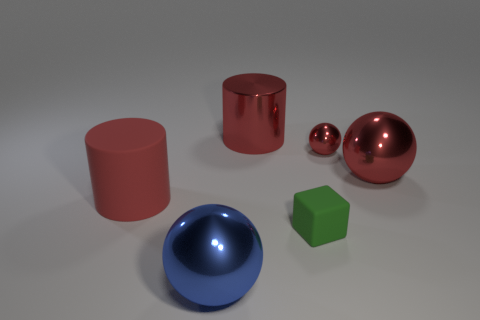There is a rubber object that is to the right of the large sphere in front of the large ball behind the blue sphere; what is its shape?
Your response must be concise. Cube. What size is the red thing that is behind the big red shiny ball and to the right of the small rubber thing?
Offer a terse response. Small. What number of small shiny balls are the same color as the large matte object?
Offer a very short reply. 1. There is a sphere that is the same color as the small metal object; what is its material?
Your response must be concise. Metal. What material is the large blue object?
Offer a terse response. Metal. Does the thing on the left side of the blue shiny sphere have the same material as the small red ball?
Your answer should be very brief. No. The tiny metal object on the right side of the blue shiny object has what shape?
Provide a succinct answer. Sphere. There is a object that is the same size as the green rubber block; what material is it?
Provide a short and direct response. Metal. How many things are either big red cylinders behind the tiny ball or spheres that are right of the big red metal cylinder?
Your response must be concise. 3. There is a cylinder that is the same material as the small block; what size is it?
Make the answer very short. Large. 